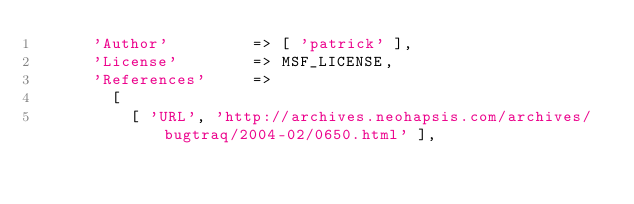<code> <loc_0><loc_0><loc_500><loc_500><_Ruby_>      'Author'         => [ 'patrick' ],
      'License'        => MSF_LICENSE,
      'References'     =>
        [
          [ 'URL', 'http://archives.neohapsis.com/archives/bugtraq/2004-02/0650.html' ],</code> 